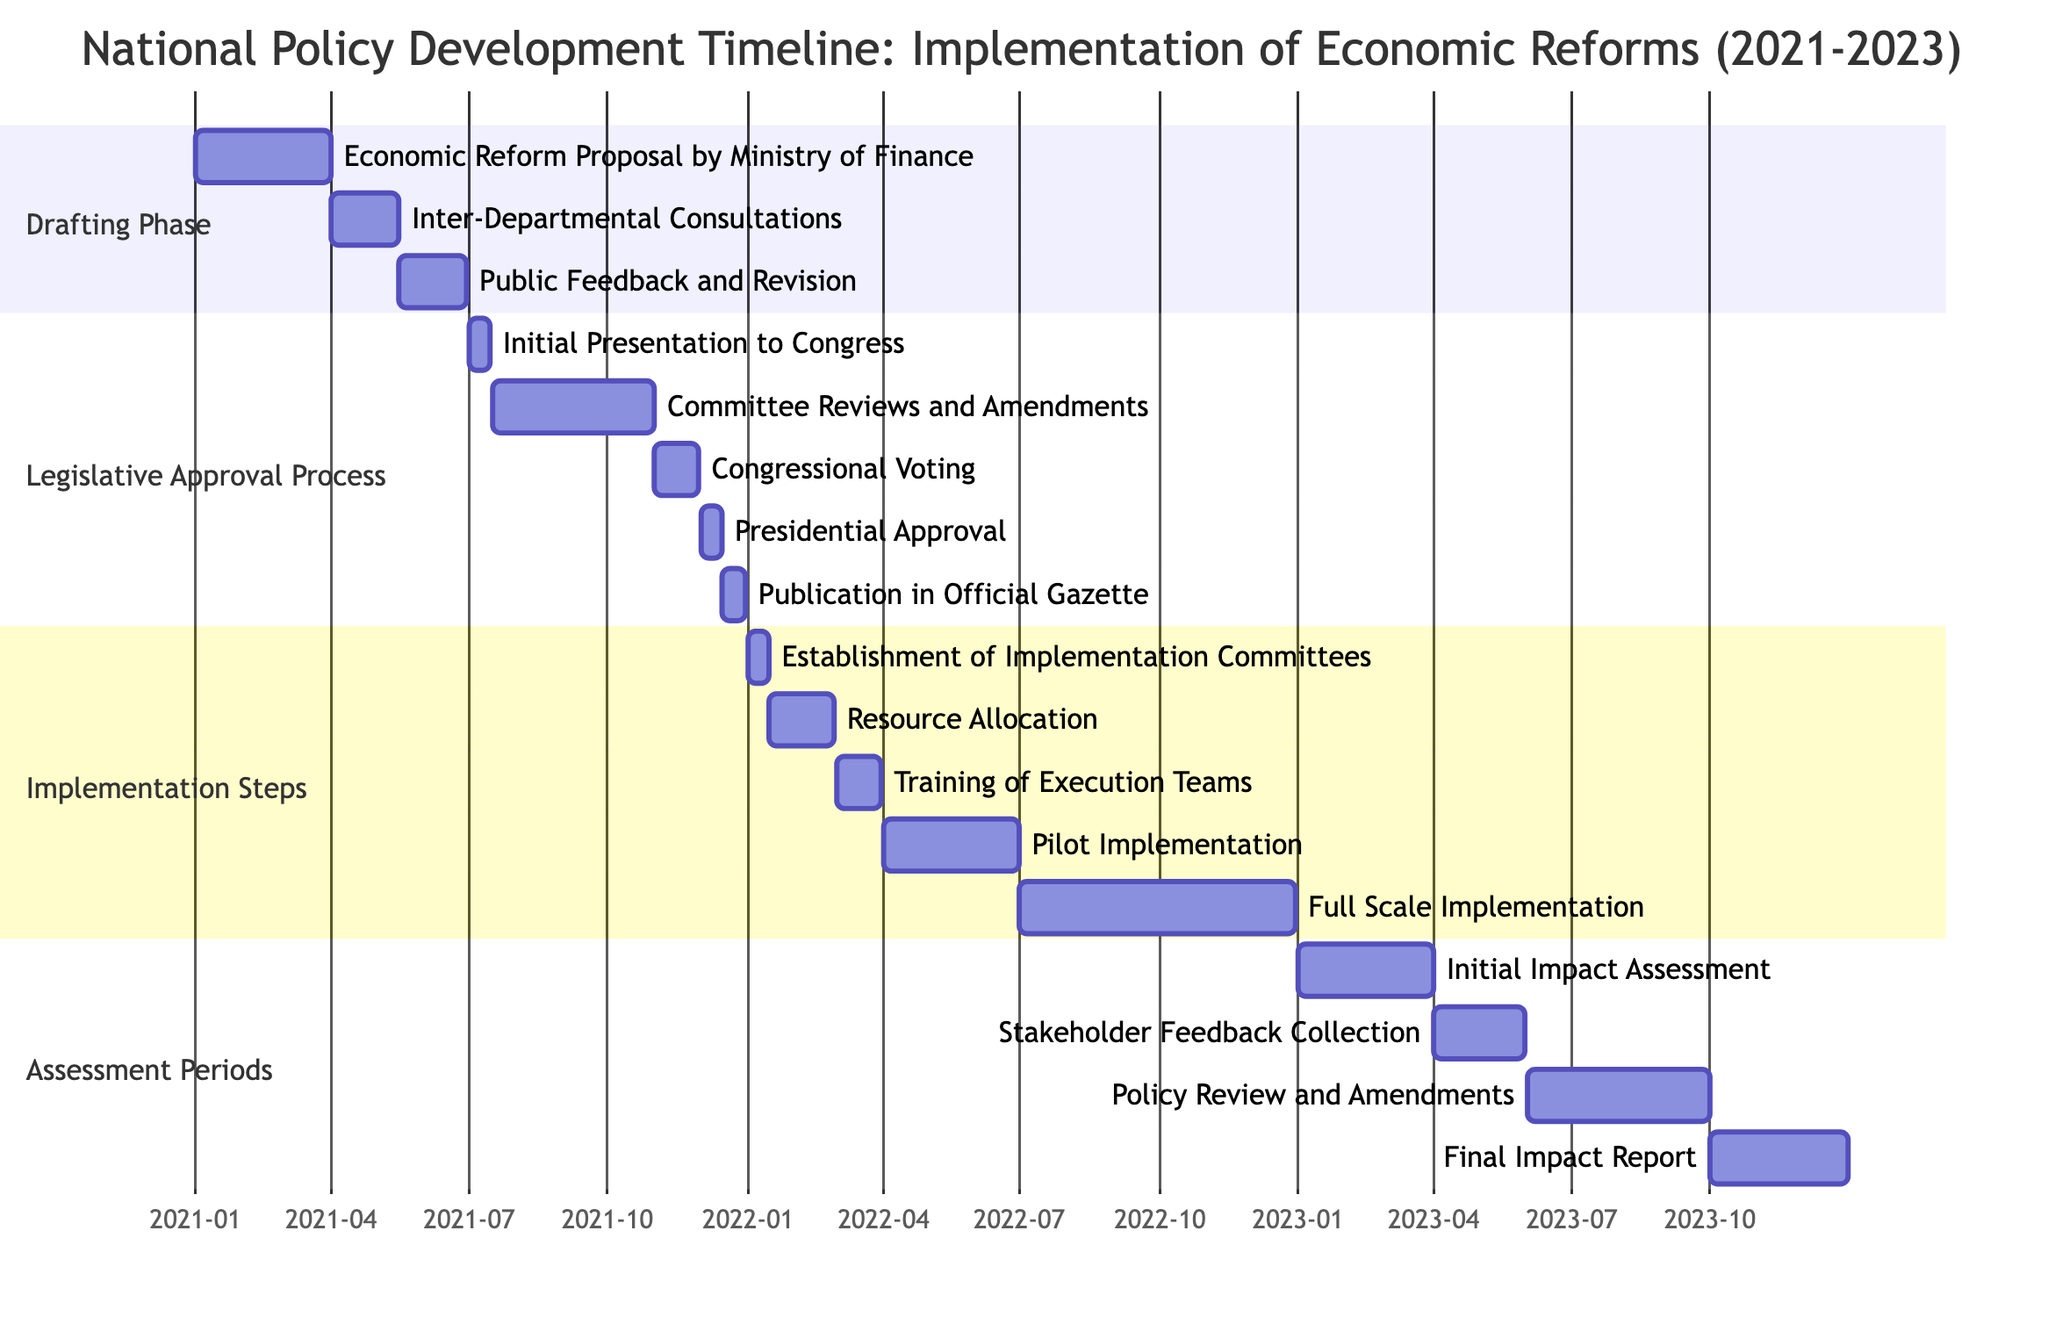What is the total duration of the "Drafting Phase"? The "Drafting Phase" starts on January 1, 2021, and ends on June 30, 2021. To calculate the duration, we count the number of days from January 1 to June 30, which totals 180 days.
Answer: 180 days Which task follows "Inter-Departmental Consultations" in the "Drafting Phase"? In the "Drafting Phase," the tasks are ordered sequentially. After "Inter-Departmental Consultations," which ends on May 15, 2021, the next task is "Public Feedback and Revision," starting on May 16, 2021.
Answer: Public Feedback and Revision What is the start date of the "Congressional Voting" task? The "Congressional Voting" task is a part of the "Legislative Approval Process." Referring to the diagram, this task starts on November 1, 2021.
Answer: November 1, 2021 How many tasks are there in the "Implementation Steps"? The "Implementation Steps" section includes five individual tasks as listed in the diagram. Counting them results in a total of five tasks.
Answer: 5 tasks Which phase includes "Initial Impact Assessment"? "Initial Impact Assessment" is part of the "Assessment Periods." The diagram shows that this phase focuses on assessing the impacts of the implemented economic reforms that began in 2023.
Answer: Assessment Periods What is the end date of the task "Stakeholder Feedback Collection"? "Stakeholder Feedback Collection" is under the "Assessment Periods" section, which starts on April 1, 2023, and ends on May 31, 2023. Therefore, the end date of this specific task is May 31, 2023.
Answer: May 31, 2023 In which year did the "Full Scale Implementation" task start? Reviewing the "Implementation Steps," "Full Scale Implementation" kicks off on July 1, 2022. Hence, this task starts in the year 2022.
Answer: 2022 How long is the "Legislative Approval Process"? The "Legislative Approval Process" runs from July 1, 2021, to December 31, 2021, covering a period of 184 days. Therefore, the process duration is 184 days.
Answer: 184 days What is the last task in the timeline? The last task on the Gantt Chart is "Final Impact Report," listed in the "Assessment Periods," with a designated time frame from October 1, 2023, to December 31, 2023. Thus, it is the final activity noted in the timeline.
Answer: Final Impact Report 